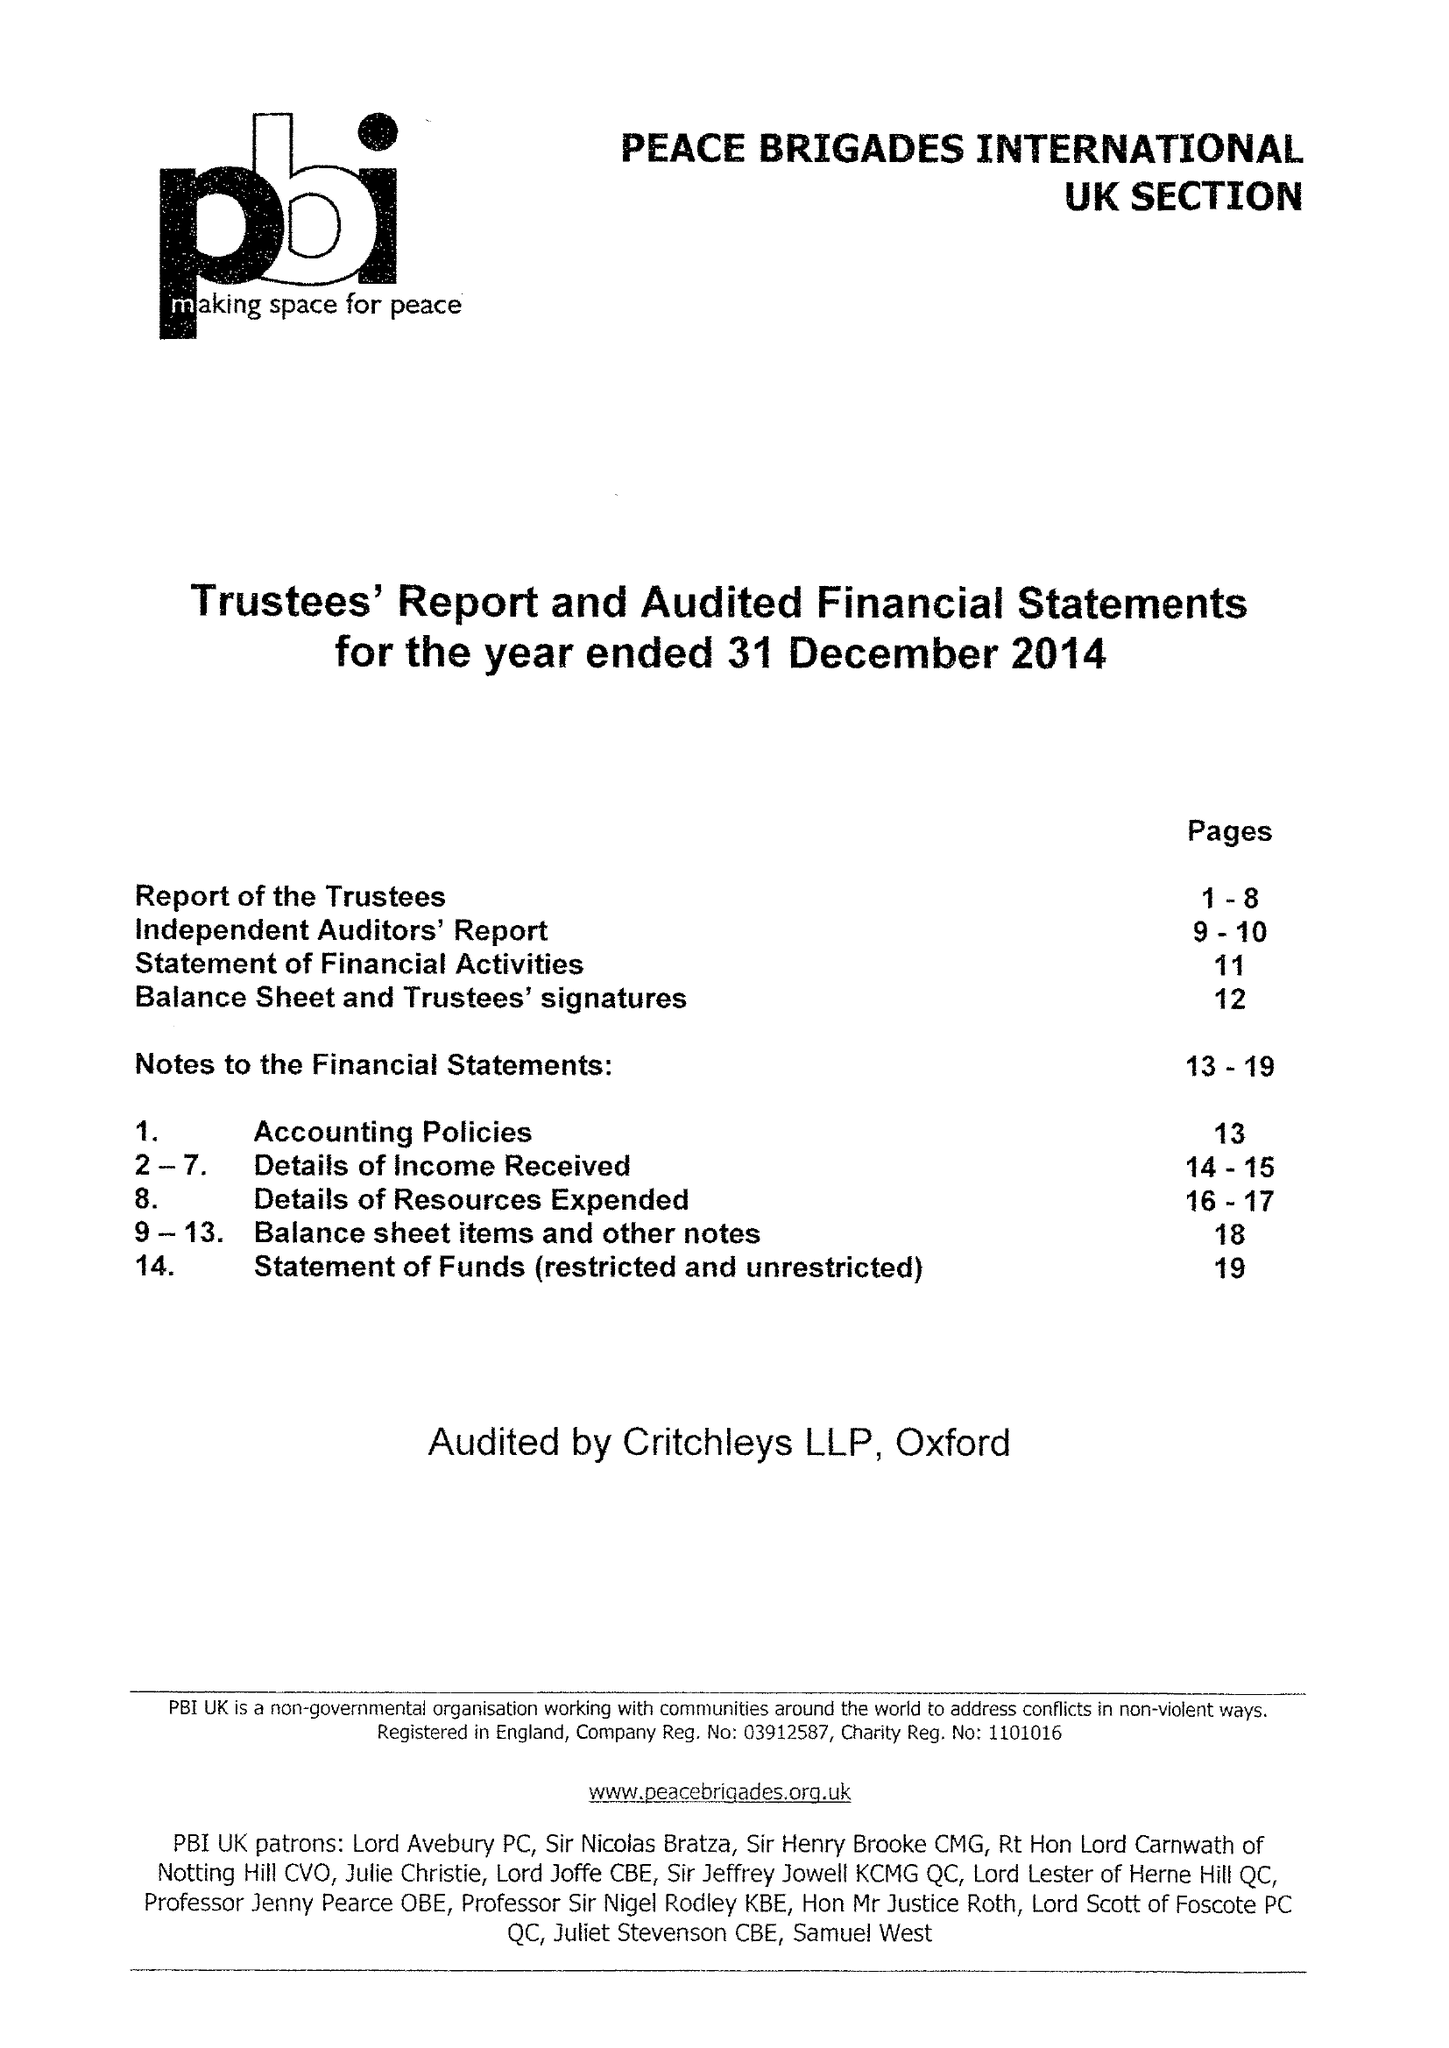What is the value for the address__street_line?
Answer the question using a single word or phrase. 1B WATERLOW ROAD 